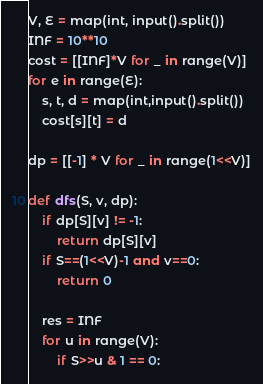<code> <loc_0><loc_0><loc_500><loc_500><_Python_>V, E = map(int, input().split())
INF = 10**10
cost = [[INF]*V for _ in range(V)]
for e in range(E):
    s, t, d = map(int,input().split())
    cost[s][t] = d

dp = [[-1] * V for _ in range(1<<V)]

def dfs(S, v, dp):
    if dp[S][v] != -1:
        return dp[S][v]
    if S==(1<<V)-1 and v==0:
        return 0

    res = INF
    for u in range(V):
        if S>>u & 1 == 0:</code> 